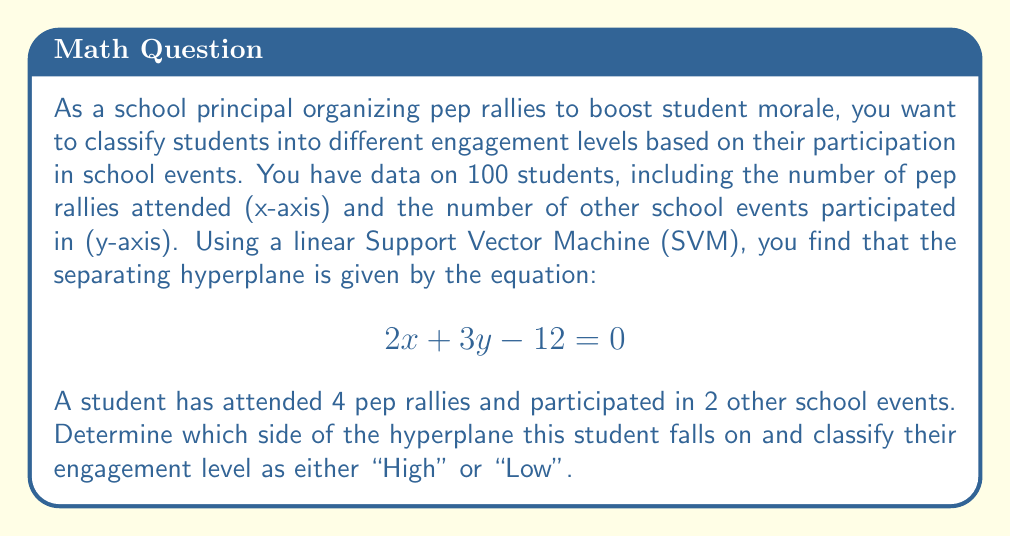Give your solution to this math problem. To solve this problem, we need to follow these steps:

1) The separating hyperplane equation is given as:
   $$2x + 3y - 12 = 0$$

2) For any point $(x, y)$, we can determine which side of the hyperplane it falls on by plugging its coordinates into the left side of the equation:
   - If $2x + 3y - 12 > 0$, the point is on one side (let's call this the "High" engagement side)
   - If $2x + 3y - 12 < 0$, the point is on the other side (let's call this the "Low" engagement side)
   - If $2x + 3y - 12 = 0$, the point is exactly on the hyperplane

3) For our student, we have:
   $x = 4$ (number of pep rallies attended)
   $y = 2$ (number of other school events participated in)

4) Let's plug these values into the left side of the equation:
   $$2(4) + 3(2) - 12$$
   $$8 + 6 - 12$$
   $$2$$

5) Since the result is positive (2 > 0), this student falls on the "High" engagement side of the hyperplane.

Therefore, based on the SVM classification, this student would be classified as having a "High" engagement level.
Answer: The student is classified as having a "High" engagement level. 